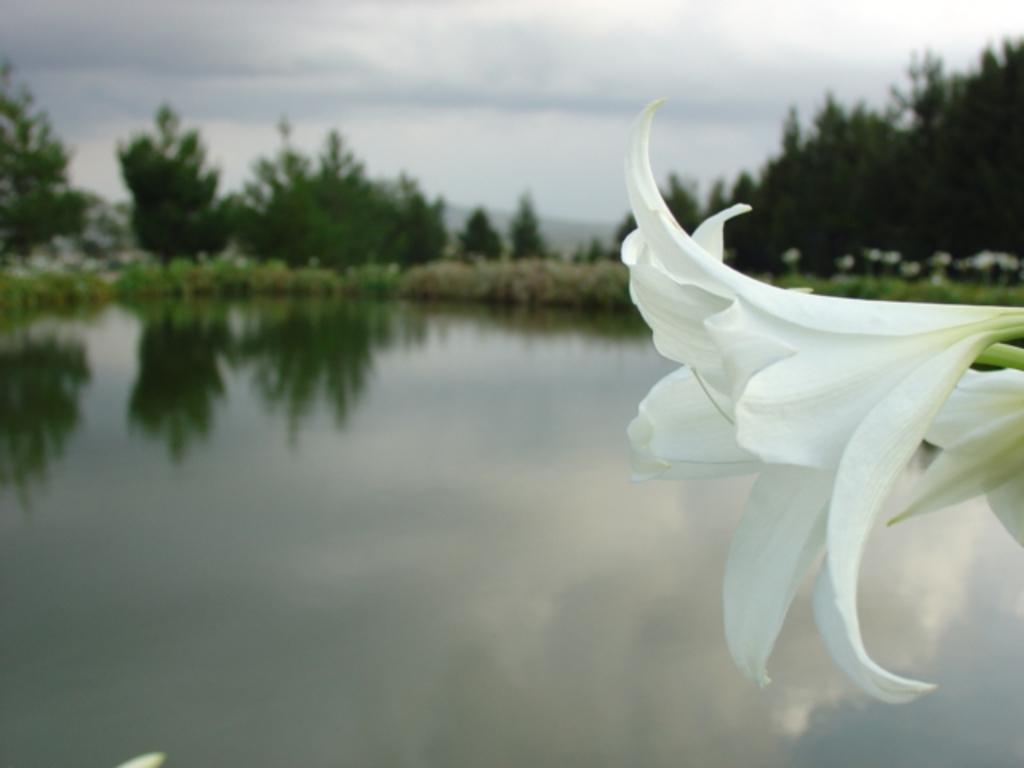In one or two sentences, can you explain what this image depicts? In this image we can see some flowers. On the backside we can see a water body, a group of plants, trees, the hills and the sky which looks cloudy. 